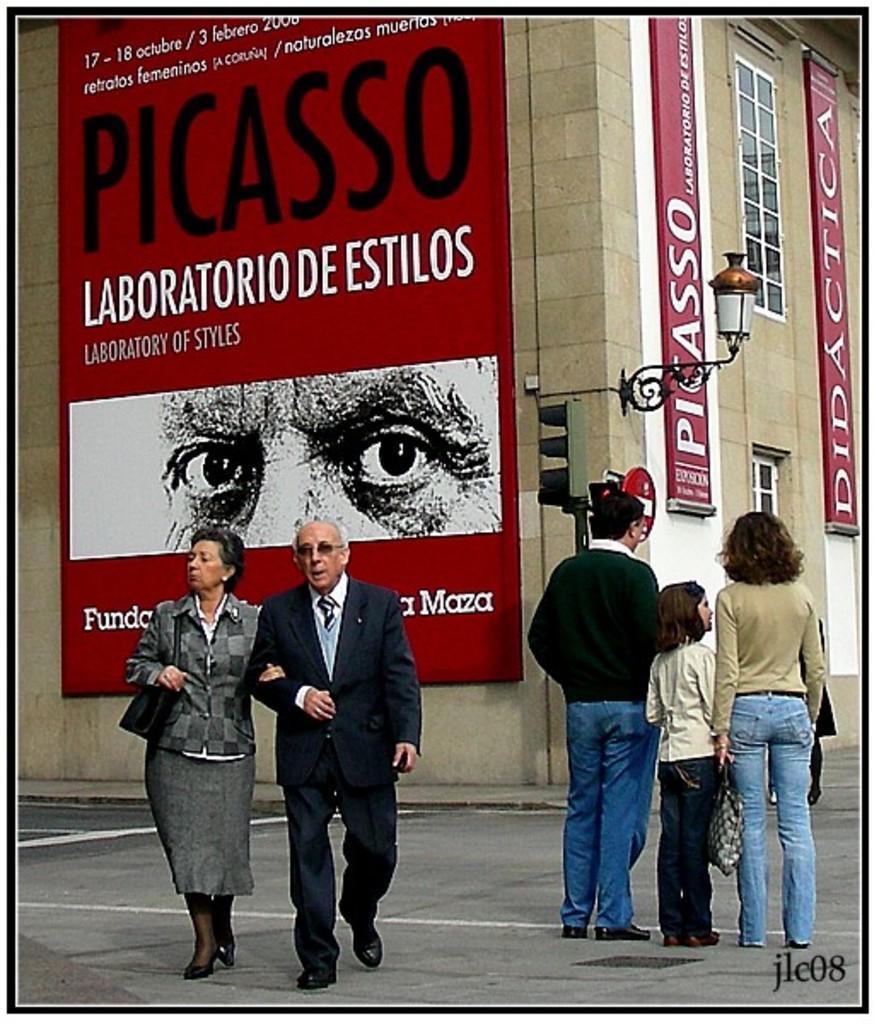Describe this image in one or two sentences. In this picture there are people on the road and we can see traffic signal. In the background of the image we can see building, light attached to the wall and boards. In the bottom right side of the image we can see text. 